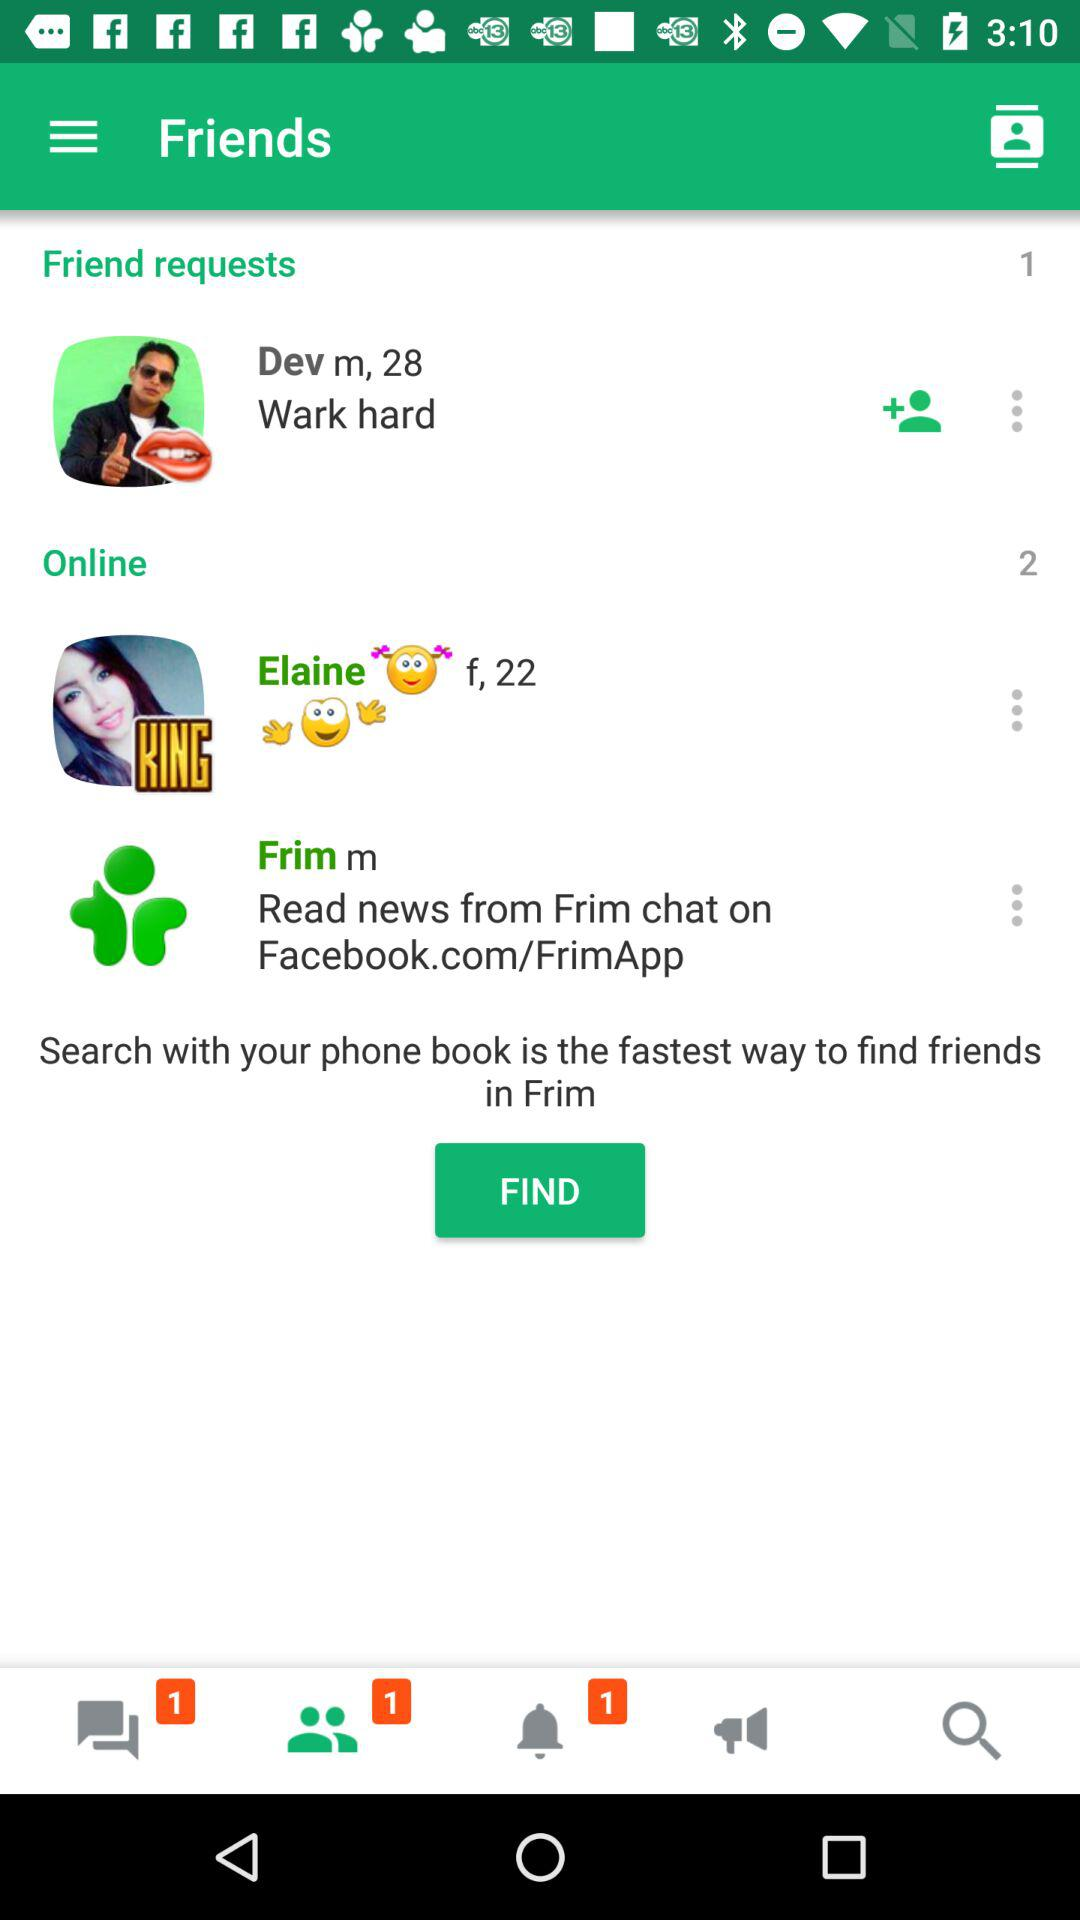How many more friends do I have than friend requests?
Answer the question using a single word or phrase. 1 